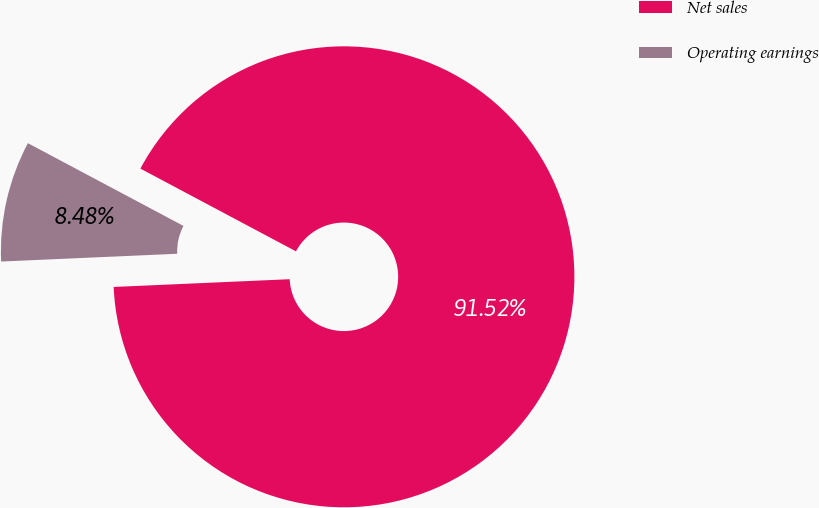Convert chart to OTSL. <chart><loc_0><loc_0><loc_500><loc_500><pie_chart><fcel>Net sales<fcel>Operating earnings<nl><fcel>91.52%<fcel>8.48%<nl></chart> 